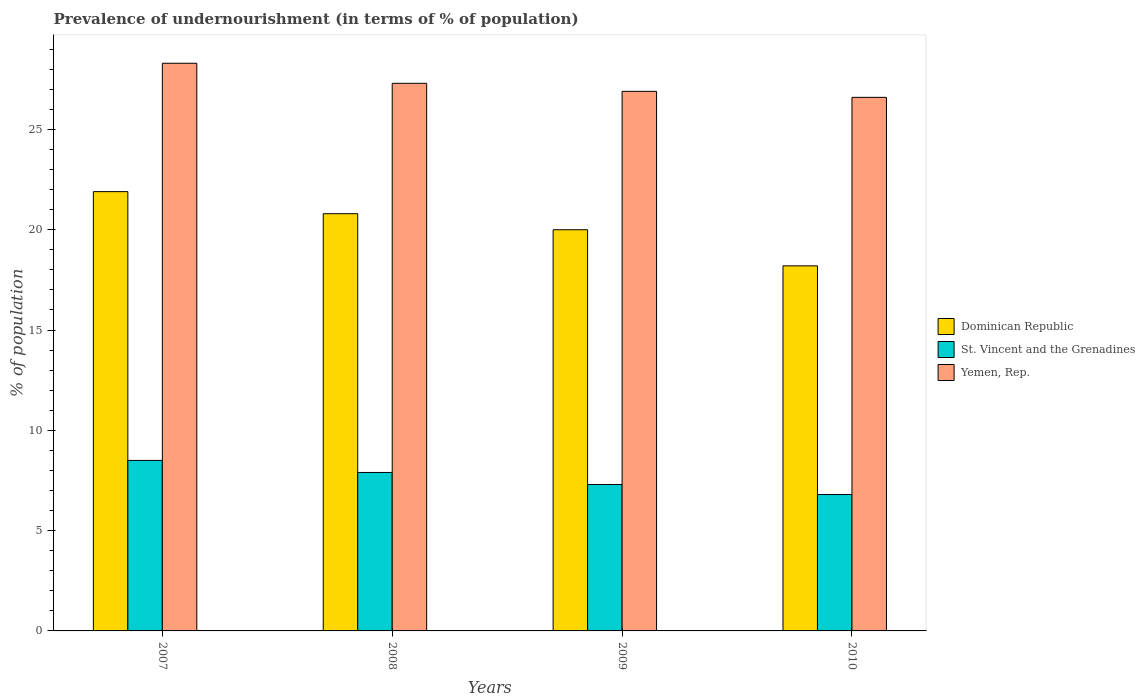How many different coloured bars are there?
Offer a terse response. 3. How many groups of bars are there?
Offer a very short reply. 4. How many bars are there on the 1st tick from the left?
Provide a short and direct response. 3. How many bars are there on the 1st tick from the right?
Provide a succinct answer. 3. What is the percentage of undernourished population in Dominican Republic in 2007?
Give a very brief answer. 21.9. Across all years, what is the maximum percentage of undernourished population in St. Vincent and the Grenadines?
Offer a terse response. 8.5. Across all years, what is the minimum percentage of undernourished population in Yemen, Rep.?
Your answer should be very brief. 26.6. What is the total percentage of undernourished population in Dominican Republic in the graph?
Offer a very short reply. 80.9. What is the difference between the percentage of undernourished population in Yemen, Rep. in 2008 and that in 2010?
Keep it short and to the point. 0.7. What is the average percentage of undernourished population in St. Vincent and the Grenadines per year?
Offer a very short reply. 7.62. In the year 2008, what is the difference between the percentage of undernourished population in Yemen, Rep. and percentage of undernourished population in Dominican Republic?
Ensure brevity in your answer.  6.5. What is the ratio of the percentage of undernourished population in Dominican Republic in 2007 to that in 2010?
Make the answer very short. 1.2. Is the percentage of undernourished population in Dominican Republic in 2008 less than that in 2009?
Your response must be concise. No. What is the difference between the highest and the second highest percentage of undernourished population in Dominican Republic?
Offer a very short reply. 1.1. What is the difference between the highest and the lowest percentage of undernourished population in Dominican Republic?
Provide a short and direct response. 3.7. In how many years, is the percentage of undernourished population in Yemen, Rep. greater than the average percentage of undernourished population in Yemen, Rep. taken over all years?
Your answer should be compact. 2. What does the 2nd bar from the left in 2010 represents?
Your answer should be very brief. St. Vincent and the Grenadines. What does the 1st bar from the right in 2010 represents?
Offer a terse response. Yemen, Rep. What is the difference between two consecutive major ticks on the Y-axis?
Ensure brevity in your answer.  5. Are the values on the major ticks of Y-axis written in scientific E-notation?
Make the answer very short. No. Does the graph contain grids?
Give a very brief answer. No. How are the legend labels stacked?
Make the answer very short. Vertical. What is the title of the graph?
Offer a terse response. Prevalence of undernourishment (in terms of % of population). What is the label or title of the Y-axis?
Your response must be concise. % of population. What is the % of population of Dominican Republic in 2007?
Ensure brevity in your answer.  21.9. What is the % of population in Yemen, Rep. in 2007?
Your answer should be very brief. 28.3. What is the % of population in Dominican Republic in 2008?
Keep it short and to the point. 20.8. What is the % of population in Yemen, Rep. in 2008?
Your response must be concise. 27.3. What is the % of population in Dominican Republic in 2009?
Offer a very short reply. 20. What is the % of population in Yemen, Rep. in 2009?
Offer a terse response. 26.9. What is the % of population of Dominican Republic in 2010?
Provide a succinct answer. 18.2. What is the % of population in St. Vincent and the Grenadines in 2010?
Offer a very short reply. 6.8. What is the % of population of Yemen, Rep. in 2010?
Keep it short and to the point. 26.6. Across all years, what is the maximum % of population in Dominican Republic?
Ensure brevity in your answer.  21.9. Across all years, what is the maximum % of population in St. Vincent and the Grenadines?
Ensure brevity in your answer.  8.5. Across all years, what is the maximum % of population of Yemen, Rep.?
Offer a terse response. 28.3. Across all years, what is the minimum % of population of Yemen, Rep.?
Provide a succinct answer. 26.6. What is the total % of population in Dominican Republic in the graph?
Keep it short and to the point. 80.9. What is the total % of population of St. Vincent and the Grenadines in the graph?
Your answer should be very brief. 30.5. What is the total % of population of Yemen, Rep. in the graph?
Provide a succinct answer. 109.1. What is the difference between the % of population in Dominican Republic in 2007 and that in 2008?
Your answer should be very brief. 1.1. What is the difference between the % of population in St. Vincent and the Grenadines in 2007 and that in 2008?
Provide a short and direct response. 0.6. What is the difference between the % of population in Yemen, Rep. in 2007 and that in 2008?
Keep it short and to the point. 1. What is the difference between the % of population in Dominican Republic in 2007 and that in 2009?
Keep it short and to the point. 1.9. What is the difference between the % of population of St. Vincent and the Grenadines in 2007 and that in 2009?
Your answer should be compact. 1.2. What is the difference between the % of population of Yemen, Rep. in 2007 and that in 2009?
Offer a terse response. 1.4. What is the difference between the % of population in Yemen, Rep. in 2007 and that in 2010?
Offer a terse response. 1.7. What is the difference between the % of population in Yemen, Rep. in 2008 and that in 2009?
Offer a terse response. 0.4. What is the difference between the % of population of Dominican Republic in 2008 and that in 2010?
Your response must be concise. 2.6. What is the difference between the % of population in Dominican Republic in 2009 and that in 2010?
Provide a succinct answer. 1.8. What is the difference between the % of population in Yemen, Rep. in 2009 and that in 2010?
Your answer should be very brief. 0.3. What is the difference between the % of population of Dominican Republic in 2007 and the % of population of Yemen, Rep. in 2008?
Your answer should be compact. -5.4. What is the difference between the % of population of St. Vincent and the Grenadines in 2007 and the % of population of Yemen, Rep. in 2008?
Offer a very short reply. -18.8. What is the difference between the % of population in Dominican Republic in 2007 and the % of population in Yemen, Rep. in 2009?
Ensure brevity in your answer.  -5. What is the difference between the % of population of St. Vincent and the Grenadines in 2007 and the % of population of Yemen, Rep. in 2009?
Give a very brief answer. -18.4. What is the difference between the % of population in St. Vincent and the Grenadines in 2007 and the % of population in Yemen, Rep. in 2010?
Your answer should be very brief. -18.1. What is the difference between the % of population in St. Vincent and the Grenadines in 2008 and the % of population in Yemen, Rep. in 2009?
Your answer should be compact. -19. What is the difference between the % of population in Dominican Republic in 2008 and the % of population in St. Vincent and the Grenadines in 2010?
Provide a short and direct response. 14. What is the difference between the % of population in St. Vincent and the Grenadines in 2008 and the % of population in Yemen, Rep. in 2010?
Your response must be concise. -18.7. What is the difference between the % of population in Dominican Republic in 2009 and the % of population in St. Vincent and the Grenadines in 2010?
Provide a succinct answer. 13.2. What is the difference between the % of population of St. Vincent and the Grenadines in 2009 and the % of population of Yemen, Rep. in 2010?
Your answer should be very brief. -19.3. What is the average % of population in Dominican Republic per year?
Provide a succinct answer. 20.23. What is the average % of population in St. Vincent and the Grenadines per year?
Give a very brief answer. 7.62. What is the average % of population in Yemen, Rep. per year?
Offer a terse response. 27.27. In the year 2007, what is the difference between the % of population of Dominican Republic and % of population of St. Vincent and the Grenadines?
Offer a very short reply. 13.4. In the year 2007, what is the difference between the % of population in St. Vincent and the Grenadines and % of population in Yemen, Rep.?
Your answer should be compact. -19.8. In the year 2008, what is the difference between the % of population in Dominican Republic and % of population in Yemen, Rep.?
Make the answer very short. -6.5. In the year 2008, what is the difference between the % of population of St. Vincent and the Grenadines and % of population of Yemen, Rep.?
Keep it short and to the point. -19.4. In the year 2009, what is the difference between the % of population of St. Vincent and the Grenadines and % of population of Yemen, Rep.?
Your response must be concise. -19.6. In the year 2010, what is the difference between the % of population of Dominican Republic and % of population of Yemen, Rep.?
Your response must be concise. -8.4. In the year 2010, what is the difference between the % of population in St. Vincent and the Grenadines and % of population in Yemen, Rep.?
Provide a short and direct response. -19.8. What is the ratio of the % of population of Dominican Republic in 2007 to that in 2008?
Offer a very short reply. 1.05. What is the ratio of the % of population in St. Vincent and the Grenadines in 2007 to that in 2008?
Make the answer very short. 1.08. What is the ratio of the % of population of Yemen, Rep. in 2007 to that in 2008?
Offer a very short reply. 1.04. What is the ratio of the % of population in Dominican Republic in 2007 to that in 2009?
Your response must be concise. 1.09. What is the ratio of the % of population of St. Vincent and the Grenadines in 2007 to that in 2009?
Give a very brief answer. 1.16. What is the ratio of the % of population in Yemen, Rep. in 2007 to that in 2009?
Your response must be concise. 1.05. What is the ratio of the % of population of Dominican Republic in 2007 to that in 2010?
Ensure brevity in your answer.  1.2. What is the ratio of the % of population in Yemen, Rep. in 2007 to that in 2010?
Provide a succinct answer. 1.06. What is the ratio of the % of population in Dominican Republic in 2008 to that in 2009?
Offer a very short reply. 1.04. What is the ratio of the % of population in St. Vincent and the Grenadines in 2008 to that in 2009?
Provide a succinct answer. 1.08. What is the ratio of the % of population in Yemen, Rep. in 2008 to that in 2009?
Keep it short and to the point. 1.01. What is the ratio of the % of population in St. Vincent and the Grenadines in 2008 to that in 2010?
Provide a short and direct response. 1.16. What is the ratio of the % of population in Yemen, Rep. in 2008 to that in 2010?
Give a very brief answer. 1.03. What is the ratio of the % of population of Dominican Republic in 2009 to that in 2010?
Keep it short and to the point. 1.1. What is the ratio of the % of population in St. Vincent and the Grenadines in 2009 to that in 2010?
Keep it short and to the point. 1.07. What is the ratio of the % of population of Yemen, Rep. in 2009 to that in 2010?
Make the answer very short. 1.01. What is the difference between the highest and the second highest % of population in Dominican Republic?
Your answer should be compact. 1.1. What is the difference between the highest and the second highest % of population of Yemen, Rep.?
Provide a short and direct response. 1. What is the difference between the highest and the lowest % of population of St. Vincent and the Grenadines?
Offer a very short reply. 1.7. 